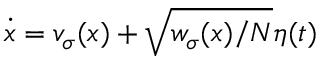Convert formula to latex. <formula><loc_0><loc_0><loc_500><loc_500>\dot { x } = v _ { \sigma } ( x ) + \sqrt { w _ { \sigma } ( x ) / N } \eta ( t )</formula> 